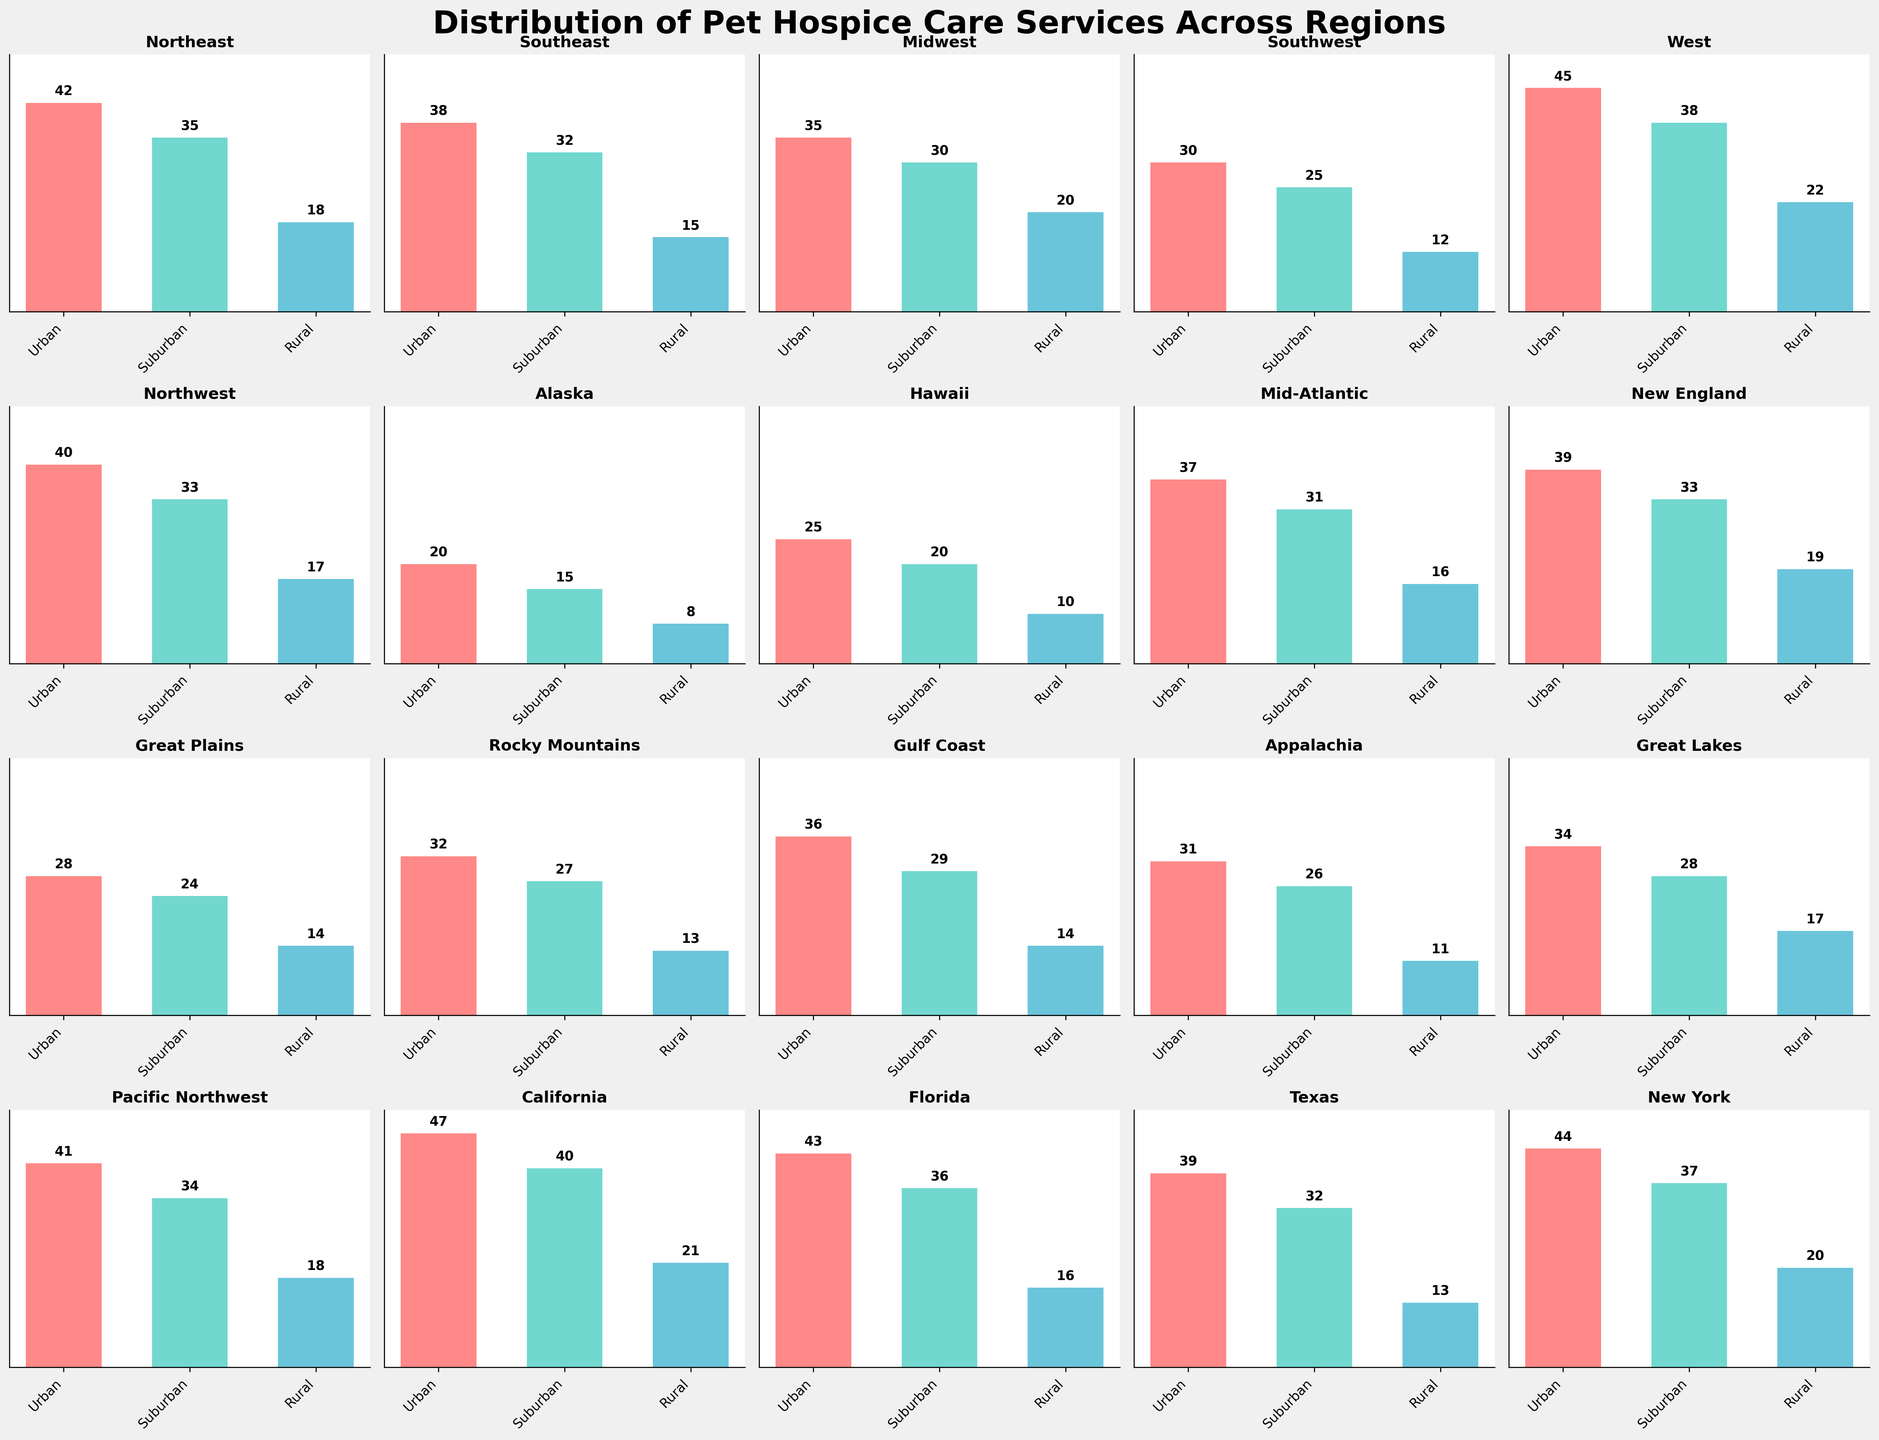Which region has the highest number of pet hospice services in Urban areas? By looking at the bar heights, compare the bars representing Urban areas across all regions. The highest bar represents the highest number of pet hospice services in Urban areas.
Answer: California Which region has the lowest number of pet hospice services in Rural areas? Compare the heights of the bars representing Rural areas across all regions. The shortest bar corresponds to the lowest number of pet hospice services in Rural areas.
Answer: Alaska In which region is the number of pet hospice services in Suburban areas approximately equal to that of Rural areas in the West? Identify the region where the bar for Suburban services is roughly the same height as the bar for Rural services in the West.
Answer: Appalachia What’s the sum of pet hospice services in Urban areas for Northeast and Southeast regions? Add the values representing Urban areas in the Northeast and Southeast from the respective bars.
Answer: 42 + 38 = 80 Which region shows the largest difference between Urban and Rural pet hospice services? Calculate the difference between the heights of the bars for Urban and Rural services in each region. Identify the region with the largest difference.
Answer: California What is the average number of Suburban pet hospice services in the Great Plains and Rocky Mountains regions? Calculate the average by summing the Suburban values for the Great Plains and Rocky Mountains and dividing by 2.
Answer: (24 + 27) / 2 = 25.5 Which region has more pet hospice services in Suburban areas, Texas or Gulf Coast? Compare the heights of the bars for Suburban areas in Texas and Gulf Coast.
Answer: Texas In how many regions is the number of pet hospice services in Suburban areas higher than in Rural areas? Count the regions where the Suburban bar is taller than the Rural bar.
Answer: 20 What is the total number of Urban pet hospice services in the Pacific Northwest and Alaska? Sum the values representing Urban areas in the Pacific Northwest and Alaska.
Answer: 41 + 20 = 61 Which region shows the smallest difference between Suburban and Rural pet hospice services? Calculate the difference between the Suburban and Rural values in each region and identify the region with the smallest difference.
Answer: Midwest 